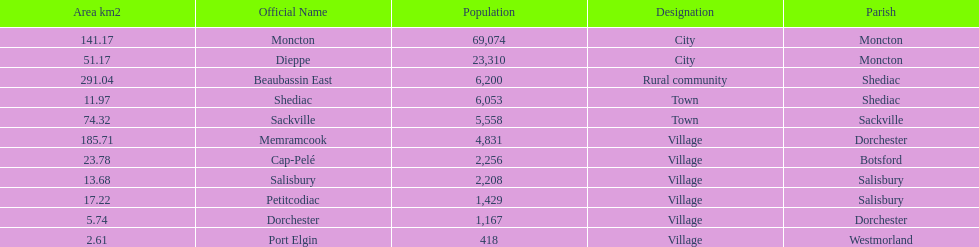The only rural community on the list Beaubassin East. Write the full table. {'header': ['Area km2', 'Official Name', 'Population', 'Designation', 'Parish'], 'rows': [['141.17', 'Moncton', '69,074', 'City', 'Moncton'], ['51.17', 'Dieppe', '23,310', 'City', 'Moncton'], ['291.04', 'Beaubassin East', '6,200', 'Rural community', 'Shediac'], ['11.97', 'Shediac', '6,053', 'Town', 'Shediac'], ['74.32', 'Sackville', '5,558', 'Town', 'Sackville'], ['185.71', 'Memramcook', '4,831', 'Village', 'Dorchester'], ['23.78', 'Cap-Pelé', '2,256', 'Village', 'Botsford'], ['13.68', 'Salisbury', '2,208', 'Village', 'Salisbury'], ['17.22', 'Petitcodiac', '1,429', 'Village', 'Salisbury'], ['5.74', 'Dorchester', '1,167', 'Village', 'Dorchester'], ['2.61', 'Port Elgin', '418', 'Village', 'Westmorland']]} 